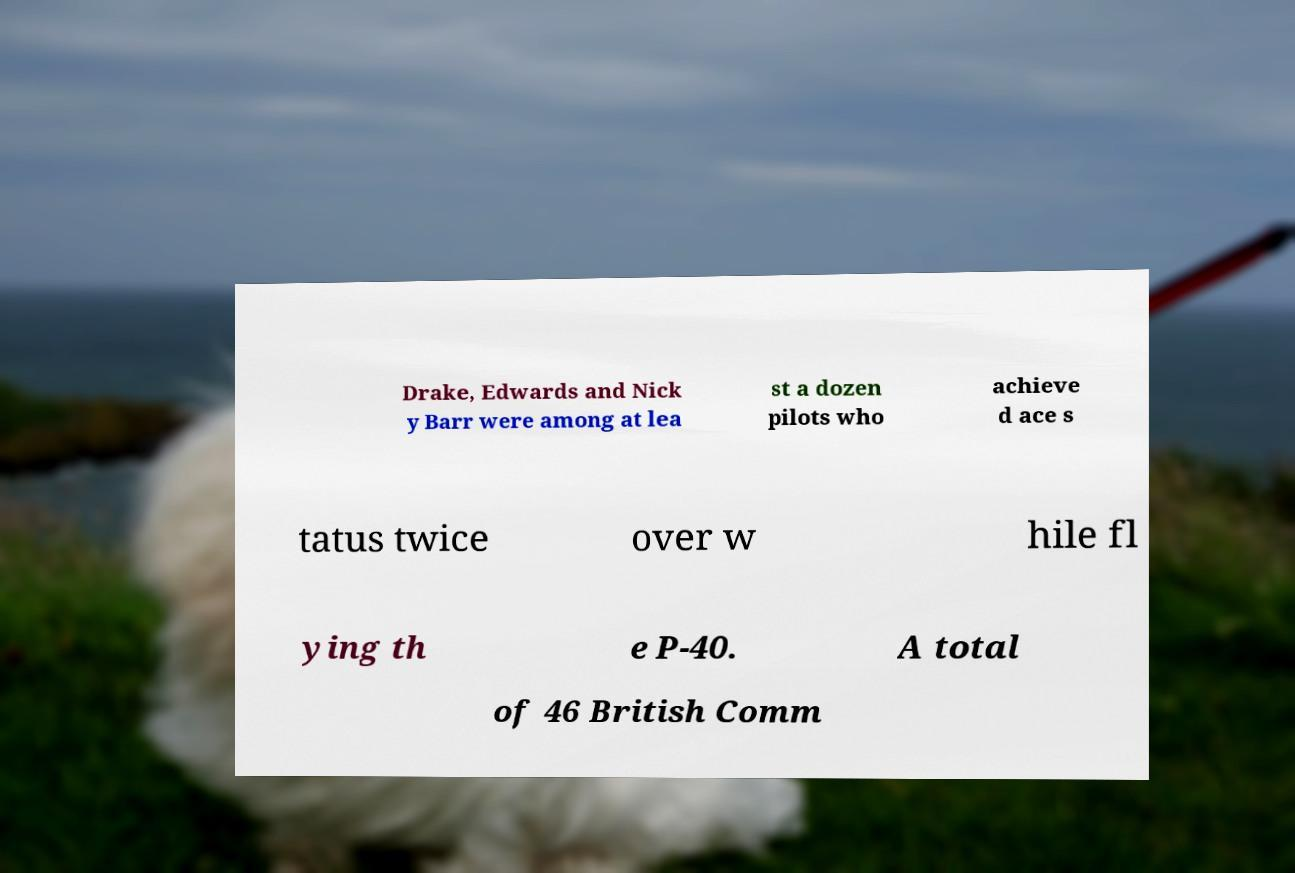Can you read and provide the text displayed in the image?This photo seems to have some interesting text. Can you extract and type it out for me? Drake, Edwards and Nick y Barr were among at lea st a dozen pilots who achieve d ace s tatus twice over w hile fl ying th e P-40. A total of 46 British Comm 